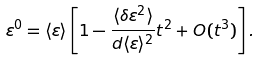Convert formula to latex. <formula><loc_0><loc_0><loc_500><loc_500>\varepsilon ^ { 0 } = \langle \varepsilon \rangle \left [ 1 - \frac { \langle \delta \varepsilon ^ { 2 } \rangle } { d \langle \varepsilon \rangle ^ { 2 } } t ^ { 2 } + O ( t ^ { 3 } ) \right ] .</formula> 